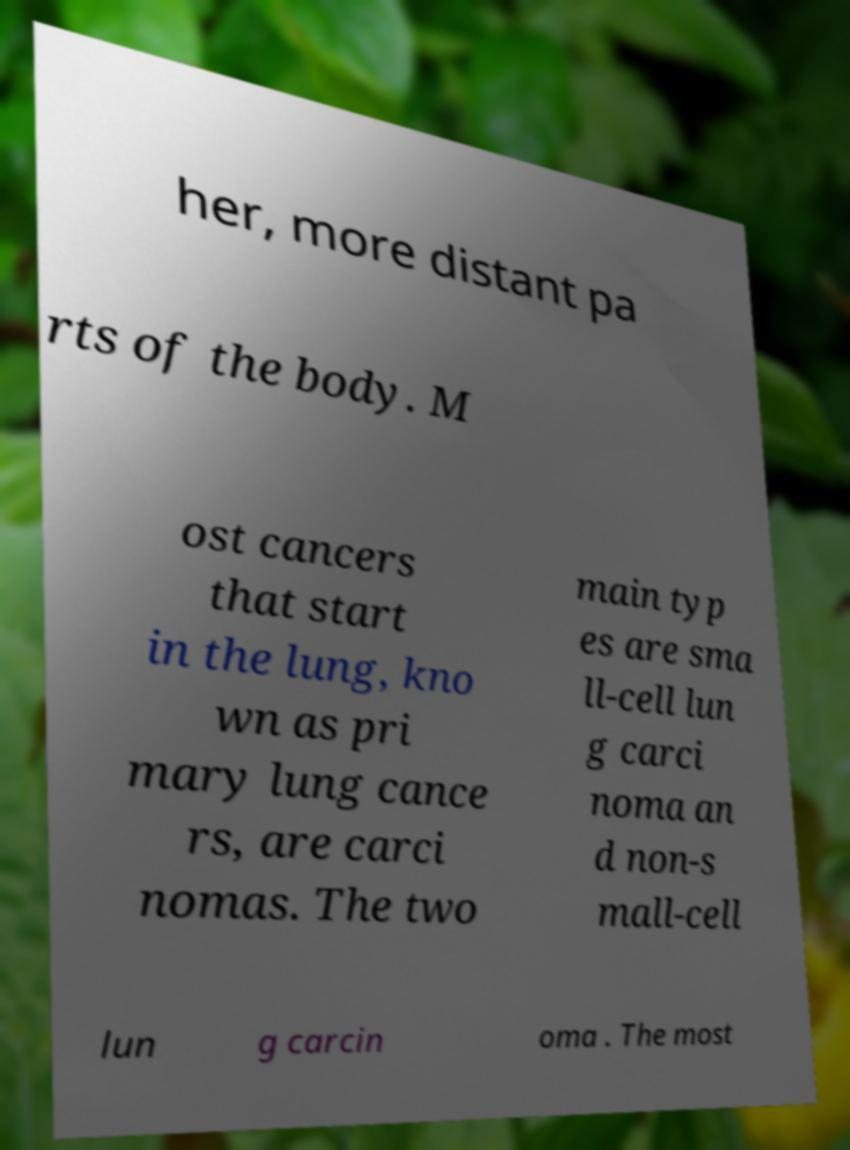For documentation purposes, I need the text within this image transcribed. Could you provide that? her, more distant pa rts of the body. M ost cancers that start in the lung, kno wn as pri mary lung cance rs, are carci nomas. The two main typ es are sma ll-cell lun g carci noma an d non-s mall-cell lun g carcin oma . The most 